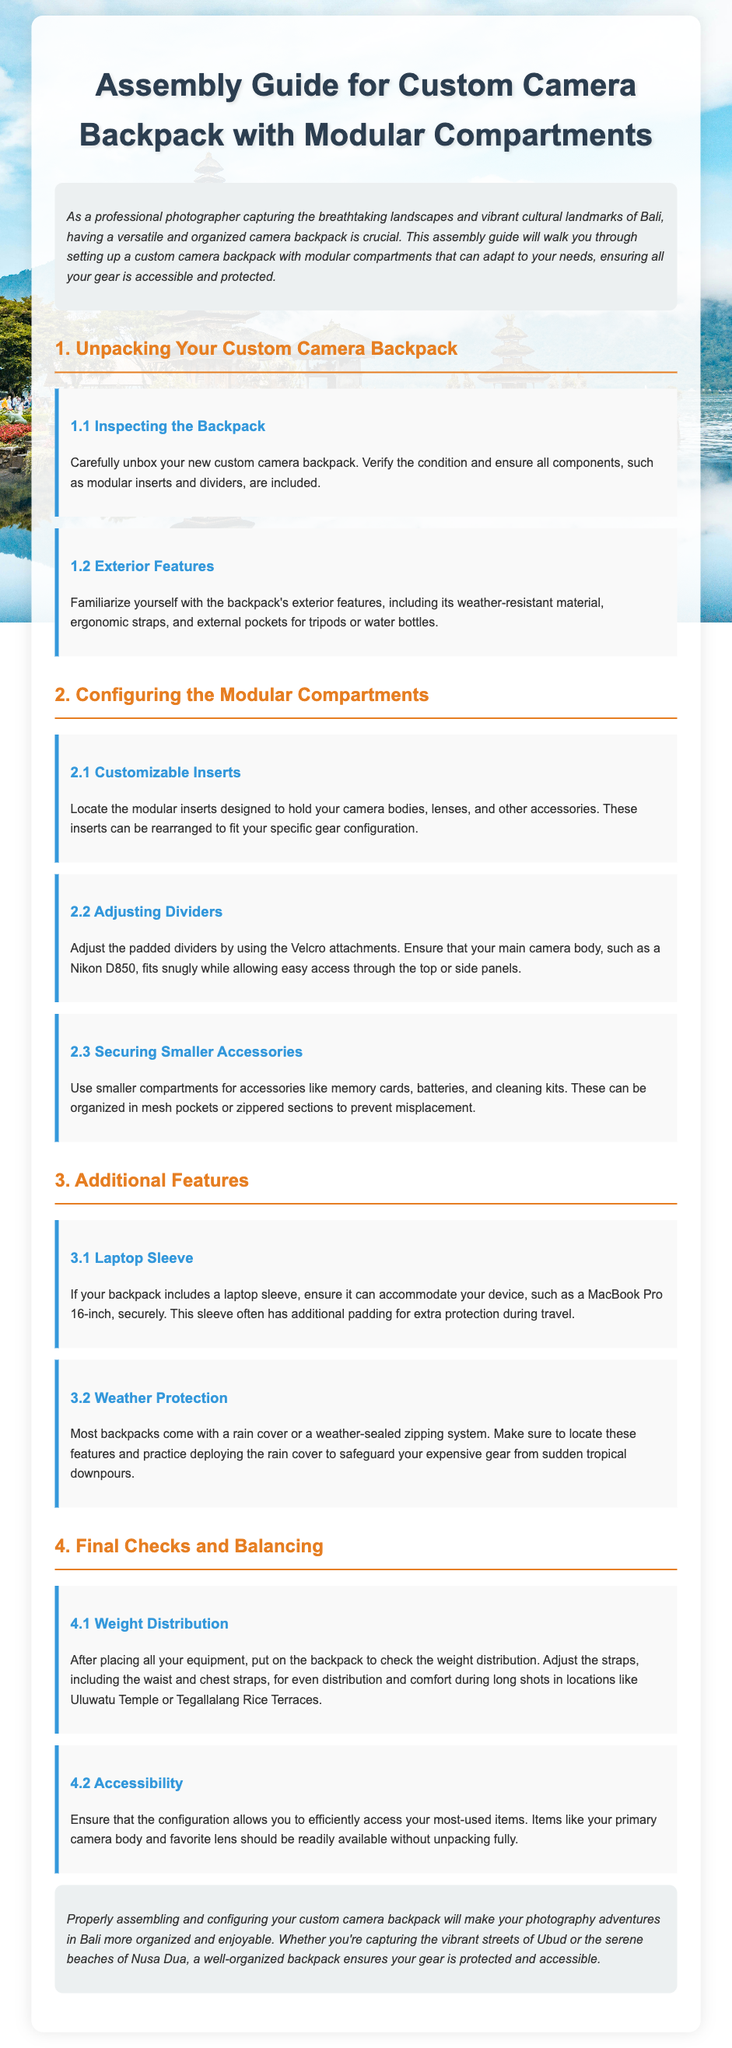What is the title of the document? The title is specified in the `<title>` tag of the HTML document.
Answer: Assembly Guide for Custom Camera Backpack What should you verify upon unpacking the backpack? The first step in the assembly guide mentions inspecting the condition and all components included.
Answer: Condition and components What is the purpose of the customizable inserts? The second section describes the purpose of inserts in holding camera bodies and lenses.
Answer: Hold camera bodies and lenses What device fits into the laptop sleeve? The relevant step specifically states a type of device that can fit securely in the sleeve.
Answer: MacBook Pro 16-inch How should you distribute the weight of the backpack? The final checks section explains adjusting straps for comfortable weight distribution.
Answer: Adjust straps Why is it important to ensure accessibility to the items? The document mentions being able to access frequently used items efficiently while photographing.
Answer: Efficient access What feature protects the backpack from rain? The additional features section discusses a specific feature for weather protection.
Answer: Rain cover How can you adjust the padded dividers? The configuration step specifically states how to make adjustments using attachments.
Answer: Velcro attachments What is emphasized as a benefit of a well-organized backpack? The conclusion summarizes the benefits of proper assembly for photography adventures.
Answer: Organization and enjoyment 